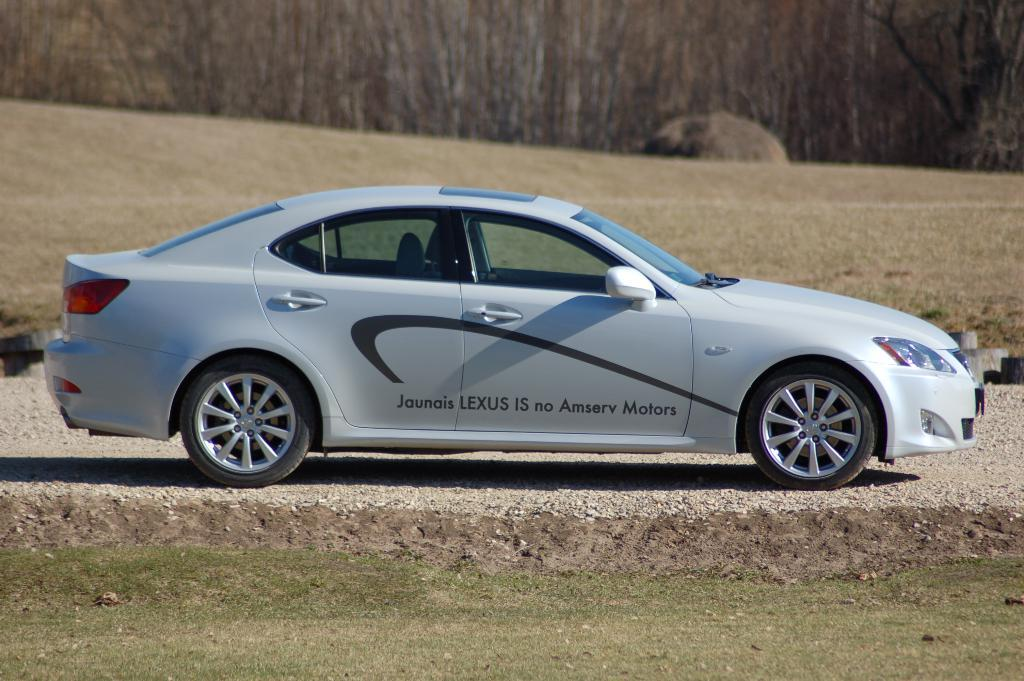What is the main subject in the center of the image? There is a car in the center of the image. What can be seen in the background of the image? There are trees in the background of the image. What type of growth can be seen on the roof of the car in the image? There is no growth visible on the roof of the car in the image, as it is a car and not a living organism. 